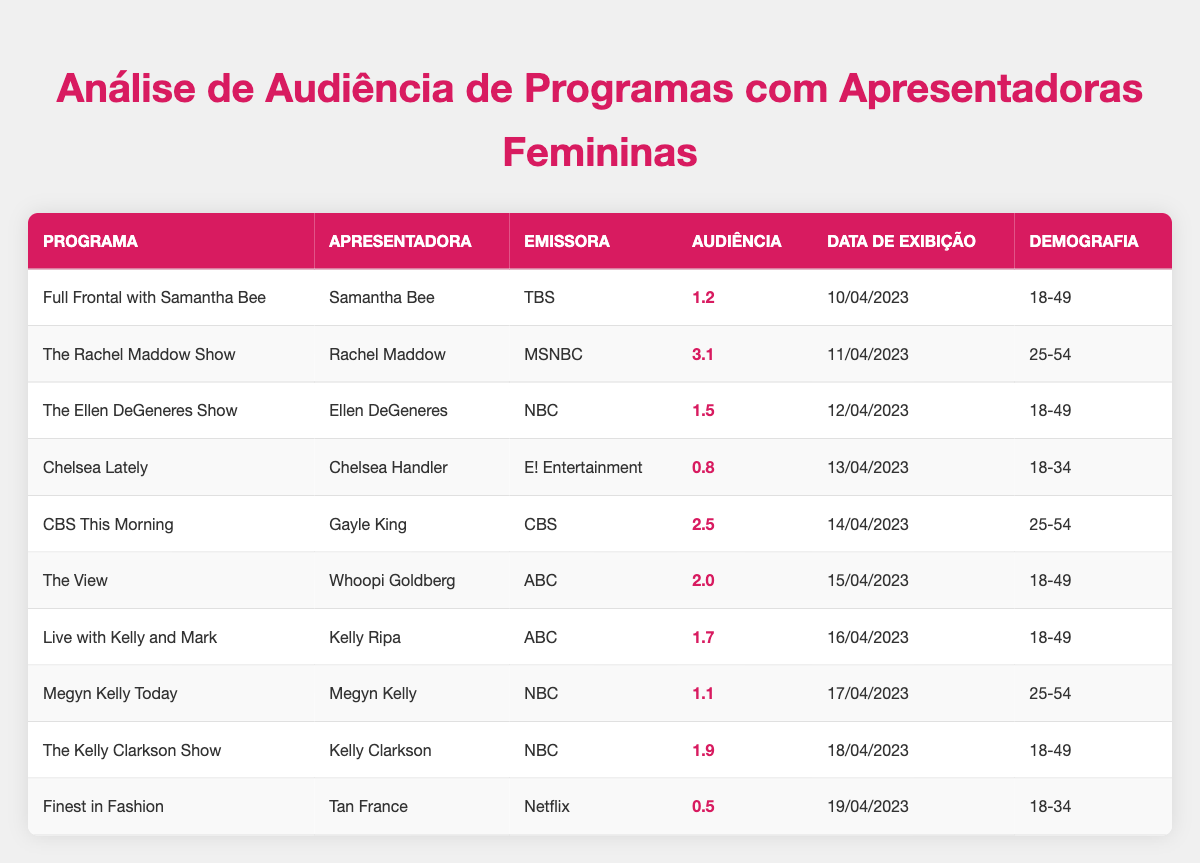What is the viewer rating of "The Rachel Maddow Show"? The viewer rating for "The Rachel Maddow Show," which is hosted by Rachel Maddow, is directly listed in the table. The value is found under the "Audiência" column.
Answer: 3.1 Which program has the lowest viewer rating? To find the lowest viewer rating, we can compare all the viewer ratings in the table. The lowest value is 0.5, which corresponds to "Finest in Fashion" hosted by Tan France.
Answer: Finest in Fashion What is the average viewer rating for programs hosted by female journalists? To calculate the average, we first identify all the viewer ratings from female hosts: 1.2 (Samantha Bee), 3.1 (Rachel Maddow), 1.5 (Ellen DeGeneres), 0.8 (Chelsea Handler), 2.5 (Gayle King), 2.0 (Whoopi Goldberg), 1.7 (Kelly Ripa), 1.1 (Megyn Kelly), and 1.9 (Kelly Clarkson). There are 9 ratings total. The sum of these ratings is 1.2 + 3.1 + 1.5 + 0.8 + 2.5 + 2.0 + 1.7 + 1.1 + 1.9 = 15.8. The average is 15.8 / 9 = 1.756, which can be rounded to 1.8.
Answer: 1.8 Is "The Kelly Clarkson Show" aired on NBC? By checking the "Emissora" column for "The Kelly Clarkson Show," we see that it is indeed listed under NBC.
Answer: Yes Which program aired on the highest-rated date? The program with the highest viewer rating is "The Rachel Maddow Show" at 3.1, which aired on 11/04/2023. No other program has a higher rating than this one based on the data given in the table.
Answer: The Rachel Maddow Show 